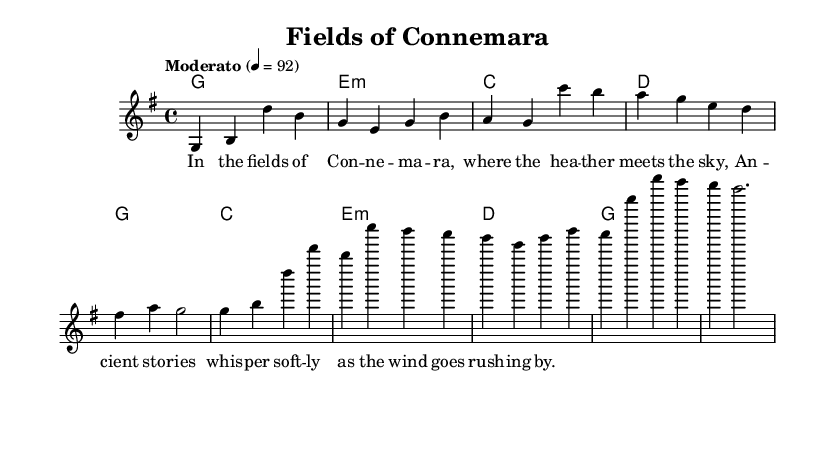What is the key signature of this music? The key signature is indicated before the staff and shows one sharp, which corresponds to G major.
Answer: G major What is the time signature? The time signature appears at the beginning of the piece, showing that there are four beats in each measure.
Answer: 4/4 What is the tempo marking of the piece? The tempo is specified in a marking above the staff, indicating a moderate pace at a quaver equals 92 beats per minute.
Answer: Moderato 4 = 92 What is the first chord in the verse? The first chord is listed in the chord mode towards the beginning, which matches the melody notes at the start of the verse.
Answer: G How many measures are in the chorus section? By counting the measures in the notation provided in the chorus, we can see that there are a total of four distinct measures.
Answer: 4 What is the structure of the piece? By analyzing the sections, we can see the piece has a verse followed by a chorus, repeating this format consistently.
Answer: Verse-Chorus What theme does the song explore? The lyrics provided describe elements of the Irish countryside, indicating themes of nature and local folklore throughout the song.
Answer: Rural Irish life 